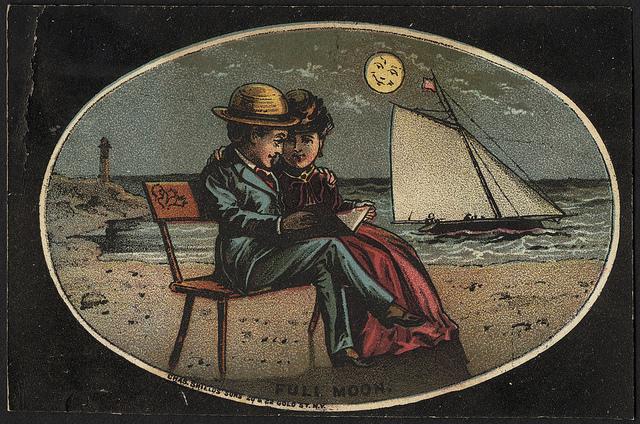Is there a sailboat in the photo?
Keep it brief. Yes. Is the moon happy?
Be succinct. Yes. How many people are sitting on the bench in this image?
Concise answer only. 2. 